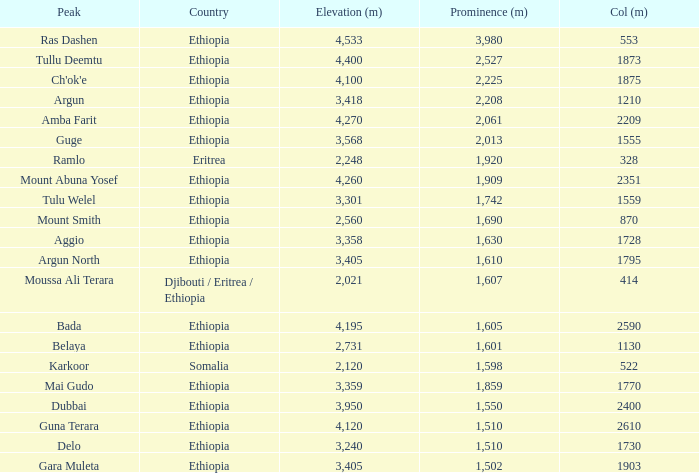What is the combined prominence in meters of the moussa ali terara peak? 1607.0. 